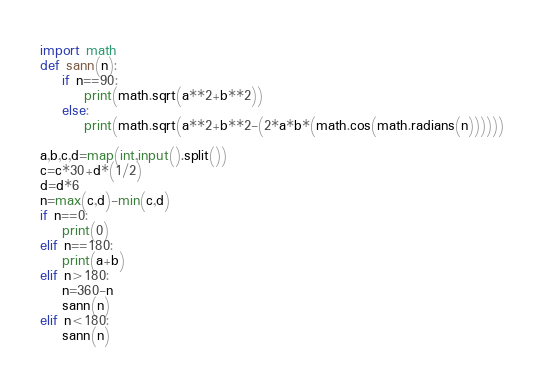<code> <loc_0><loc_0><loc_500><loc_500><_Python_>import math
def sann(n):
    if n==90:
        print(math.sqrt(a**2+b**2))
    else:
        print(math.sqrt(a**2+b**2-(2*a*b*(math.cos(math.radians(n))))))

a,b,c,d=map(int,input().split())
c=c*30+d*(1/2)
d=d*6
n=max(c,d)-min(c,d)
if n==0:
    print(0)
elif n==180:
    print(a+b)
elif n>180:
    n=360-n
    sann(n)
elif n<180:
    sann(n)</code> 